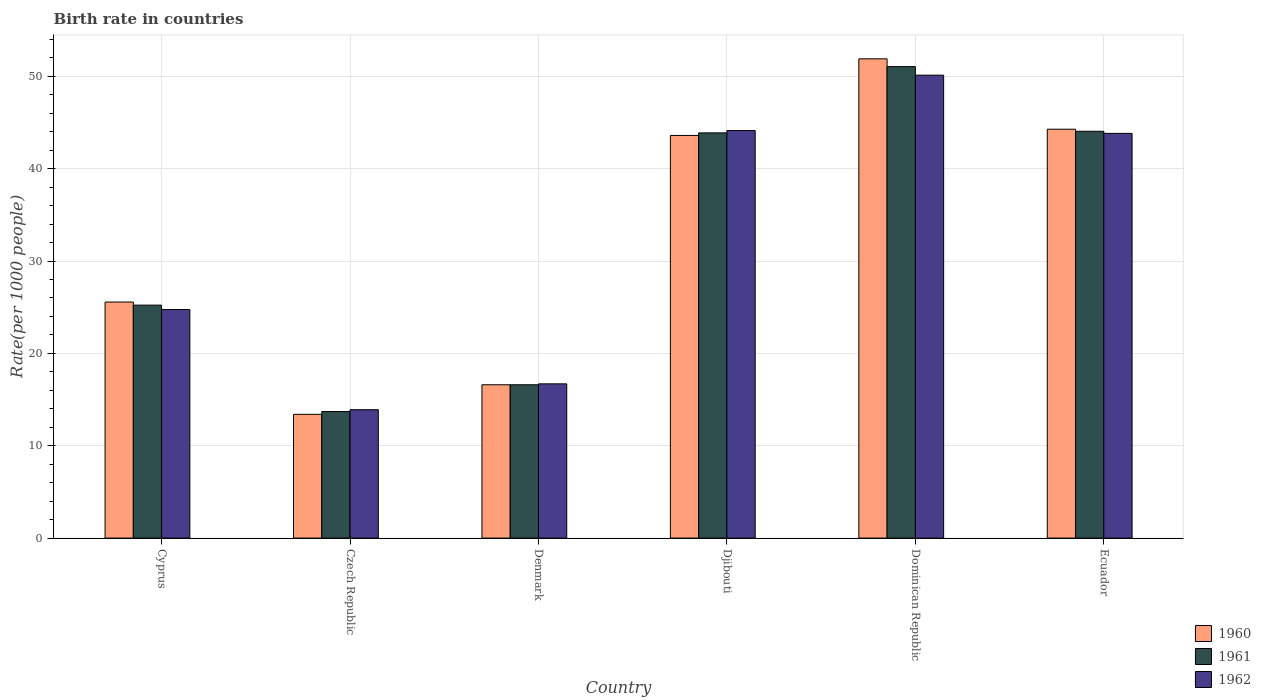How many groups of bars are there?
Your response must be concise. 6. Are the number of bars per tick equal to the number of legend labels?
Your response must be concise. Yes. How many bars are there on the 4th tick from the right?
Make the answer very short. 3. What is the label of the 1st group of bars from the left?
Keep it short and to the point. Cyprus. What is the birth rate in 1961 in Czech Republic?
Offer a very short reply. 13.7. Across all countries, what is the maximum birth rate in 1962?
Provide a short and direct response. 50.12. In which country was the birth rate in 1962 maximum?
Provide a succinct answer. Dominican Republic. In which country was the birth rate in 1960 minimum?
Your answer should be very brief. Czech Republic. What is the total birth rate in 1960 in the graph?
Ensure brevity in your answer.  195.31. What is the difference between the birth rate in 1962 in Czech Republic and that in Djibouti?
Make the answer very short. -30.23. What is the difference between the birth rate in 1962 in Djibouti and the birth rate in 1961 in Dominican Republic?
Provide a short and direct response. -6.92. What is the average birth rate in 1962 per country?
Provide a succinct answer. 32.24. What is the ratio of the birth rate in 1960 in Czech Republic to that in Ecuador?
Ensure brevity in your answer.  0.3. Is the difference between the birth rate in 1960 in Djibouti and Ecuador greater than the difference between the birth rate in 1962 in Djibouti and Ecuador?
Offer a very short reply. No. What is the difference between the highest and the second highest birth rate in 1960?
Your answer should be compact. -8.29. What is the difference between the highest and the lowest birth rate in 1961?
Keep it short and to the point. 37.35. Is the sum of the birth rate in 1961 in Czech Republic and Dominican Republic greater than the maximum birth rate in 1960 across all countries?
Provide a succinct answer. Yes. What does the 2nd bar from the right in Djibouti represents?
Make the answer very short. 1961. Is it the case that in every country, the sum of the birth rate in 1960 and birth rate in 1961 is greater than the birth rate in 1962?
Keep it short and to the point. Yes. How many bars are there?
Provide a succinct answer. 18. Are all the bars in the graph horizontal?
Make the answer very short. No. How many countries are there in the graph?
Keep it short and to the point. 6. Are the values on the major ticks of Y-axis written in scientific E-notation?
Ensure brevity in your answer.  No. Does the graph contain any zero values?
Ensure brevity in your answer.  No. Does the graph contain grids?
Keep it short and to the point. Yes. How many legend labels are there?
Keep it short and to the point. 3. What is the title of the graph?
Ensure brevity in your answer.  Birth rate in countries. What is the label or title of the Y-axis?
Your answer should be very brief. Rate(per 1000 people). What is the Rate(per 1000 people) of 1960 in Cyprus?
Offer a very short reply. 25.56. What is the Rate(per 1000 people) of 1961 in Cyprus?
Your response must be concise. 25.22. What is the Rate(per 1000 people) in 1962 in Cyprus?
Give a very brief answer. 24.75. What is the Rate(per 1000 people) of 1962 in Czech Republic?
Provide a short and direct response. 13.9. What is the Rate(per 1000 people) of 1960 in Denmark?
Offer a terse response. 16.6. What is the Rate(per 1000 people) in 1960 in Djibouti?
Ensure brevity in your answer.  43.59. What is the Rate(per 1000 people) of 1961 in Djibouti?
Offer a very short reply. 43.87. What is the Rate(per 1000 people) in 1962 in Djibouti?
Provide a succinct answer. 44.12. What is the Rate(per 1000 people) in 1960 in Dominican Republic?
Keep it short and to the point. 51.89. What is the Rate(per 1000 people) in 1961 in Dominican Republic?
Make the answer very short. 51.05. What is the Rate(per 1000 people) in 1962 in Dominican Republic?
Provide a short and direct response. 50.12. What is the Rate(per 1000 people) in 1960 in Ecuador?
Ensure brevity in your answer.  44.27. What is the Rate(per 1000 people) in 1961 in Ecuador?
Provide a short and direct response. 44.05. What is the Rate(per 1000 people) of 1962 in Ecuador?
Your response must be concise. 43.82. Across all countries, what is the maximum Rate(per 1000 people) of 1960?
Provide a short and direct response. 51.89. Across all countries, what is the maximum Rate(per 1000 people) of 1961?
Ensure brevity in your answer.  51.05. Across all countries, what is the maximum Rate(per 1000 people) of 1962?
Give a very brief answer. 50.12. Across all countries, what is the minimum Rate(per 1000 people) of 1962?
Your response must be concise. 13.9. What is the total Rate(per 1000 people) of 1960 in the graph?
Provide a succinct answer. 195.31. What is the total Rate(per 1000 people) of 1961 in the graph?
Give a very brief answer. 194.49. What is the total Rate(per 1000 people) in 1962 in the graph?
Ensure brevity in your answer.  193.41. What is the difference between the Rate(per 1000 people) in 1960 in Cyprus and that in Czech Republic?
Offer a terse response. 12.16. What is the difference between the Rate(per 1000 people) in 1961 in Cyprus and that in Czech Republic?
Offer a very short reply. 11.52. What is the difference between the Rate(per 1000 people) in 1962 in Cyprus and that in Czech Republic?
Provide a short and direct response. 10.85. What is the difference between the Rate(per 1000 people) of 1960 in Cyprus and that in Denmark?
Provide a short and direct response. 8.96. What is the difference between the Rate(per 1000 people) in 1961 in Cyprus and that in Denmark?
Provide a short and direct response. 8.62. What is the difference between the Rate(per 1000 people) in 1962 in Cyprus and that in Denmark?
Your response must be concise. 8.05. What is the difference between the Rate(per 1000 people) in 1960 in Cyprus and that in Djibouti?
Your answer should be compact. -18.04. What is the difference between the Rate(per 1000 people) of 1961 in Cyprus and that in Djibouti?
Keep it short and to the point. -18.65. What is the difference between the Rate(per 1000 people) of 1962 in Cyprus and that in Djibouti?
Your answer should be compact. -19.38. What is the difference between the Rate(per 1000 people) of 1960 in Cyprus and that in Dominican Republic?
Offer a very short reply. -26.33. What is the difference between the Rate(per 1000 people) in 1961 in Cyprus and that in Dominican Republic?
Offer a very short reply. -25.83. What is the difference between the Rate(per 1000 people) of 1962 in Cyprus and that in Dominican Republic?
Your response must be concise. -25.38. What is the difference between the Rate(per 1000 people) in 1960 in Cyprus and that in Ecuador?
Make the answer very short. -18.71. What is the difference between the Rate(per 1000 people) of 1961 in Cyprus and that in Ecuador?
Keep it short and to the point. -18.82. What is the difference between the Rate(per 1000 people) of 1962 in Cyprus and that in Ecuador?
Your answer should be compact. -19.07. What is the difference between the Rate(per 1000 people) in 1961 in Czech Republic and that in Denmark?
Make the answer very short. -2.9. What is the difference between the Rate(per 1000 people) in 1962 in Czech Republic and that in Denmark?
Keep it short and to the point. -2.8. What is the difference between the Rate(per 1000 people) of 1960 in Czech Republic and that in Djibouti?
Your answer should be very brief. -30.2. What is the difference between the Rate(per 1000 people) of 1961 in Czech Republic and that in Djibouti?
Your response must be concise. -30.17. What is the difference between the Rate(per 1000 people) in 1962 in Czech Republic and that in Djibouti?
Offer a very short reply. -30.23. What is the difference between the Rate(per 1000 people) of 1960 in Czech Republic and that in Dominican Republic?
Provide a short and direct response. -38.49. What is the difference between the Rate(per 1000 people) in 1961 in Czech Republic and that in Dominican Republic?
Your answer should be very brief. -37.35. What is the difference between the Rate(per 1000 people) of 1962 in Czech Republic and that in Dominican Republic?
Offer a very short reply. -36.22. What is the difference between the Rate(per 1000 people) of 1960 in Czech Republic and that in Ecuador?
Keep it short and to the point. -30.87. What is the difference between the Rate(per 1000 people) of 1961 in Czech Republic and that in Ecuador?
Offer a very short reply. -30.35. What is the difference between the Rate(per 1000 people) in 1962 in Czech Republic and that in Ecuador?
Give a very brief answer. -29.92. What is the difference between the Rate(per 1000 people) of 1960 in Denmark and that in Djibouti?
Offer a very short reply. -27. What is the difference between the Rate(per 1000 people) of 1961 in Denmark and that in Djibouti?
Keep it short and to the point. -27.27. What is the difference between the Rate(per 1000 people) in 1962 in Denmark and that in Djibouti?
Your response must be concise. -27.43. What is the difference between the Rate(per 1000 people) of 1960 in Denmark and that in Dominican Republic?
Provide a short and direct response. -35.29. What is the difference between the Rate(per 1000 people) of 1961 in Denmark and that in Dominican Republic?
Offer a very short reply. -34.45. What is the difference between the Rate(per 1000 people) of 1962 in Denmark and that in Dominican Republic?
Ensure brevity in your answer.  -33.42. What is the difference between the Rate(per 1000 people) in 1960 in Denmark and that in Ecuador?
Offer a very short reply. -27.67. What is the difference between the Rate(per 1000 people) in 1961 in Denmark and that in Ecuador?
Keep it short and to the point. -27.45. What is the difference between the Rate(per 1000 people) of 1962 in Denmark and that in Ecuador?
Your answer should be very brief. -27.12. What is the difference between the Rate(per 1000 people) in 1960 in Djibouti and that in Dominican Republic?
Offer a very short reply. -8.29. What is the difference between the Rate(per 1000 people) in 1961 in Djibouti and that in Dominican Republic?
Your response must be concise. -7.18. What is the difference between the Rate(per 1000 people) of 1962 in Djibouti and that in Dominican Republic?
Your answer should be compact. -6. What is the difference between the Rate(per 1000 people) in 1960 in Djibouti and that in Ecuador?
Offer a terse response. -0.68. What is the difference between the Rate(per 1000 people) of 1961 in Djibouti and that in Ecuador?
Your answer should be very brief. -0.17. What is the difference between the Rate(per 1000 people) in 1962 in Djibouti and that in Ecuador?
Provide a succinct answer. 0.31. What is the difference between the Rate(per 1000 people) of 1960 in Dominican Republic and that in Ecuador?
Offer a terse response. 7.62. What is the difference between the Rate(per 1000 people) of 1961 in Dominican Republic and that in Ecuador?
Make the answer very short. 7. What is the difference between the Rate(per 1000 people) in 1962 in Dominican Republic and that in Ecuador?
Provide a short and direct response. 6.3. What is the difference between the Rate(per 1000 people) in 1960 in Cyprus and the Rate(per 1000 people) in 1961 in Czech Republic?
Provide a short and direct response. 11.86. What is the difference between the Rate(per 1000 people) of 1960 in Cyprus and the Rate(per 1000 people) of 1962 in Czech Republic?
Your answer should be compact. 11.66. What is the difference between the Rate(per 1000 people) in 1961 in Cyprus and the Rate(per 1000 people) in 1962 in Czech Republic?
Your answer should be very brief. 11.32. What is the difference between the Rate(per 1000 people) in 1960 in Cyprus and the Rate(per 1000 people) in 1961 in Denmark?
Offer a terse response. 8.96. What is the difference between the Rate(per 1000 people) in 1960 in Cyprus and the Rate(per 1000 people) in 1962 in Denmark?
Keep it short and to the point. 8.86. What is the difference between the Rate(per 1000 people) of 1961 in Cyprus and the Rate(per 1000 people) of 1962 in Denmark?
Offer a very short reply. 8.52. What is the difference between the Rate(per 1000 people) of 1960 in Cyprus and the Rate(per 1000 people) of 1961 in Djibouti?
Provide a succinct answer. -18.31. What is the difference between the Rate(per 1000 people) in 1960 in Cyprus and the Rate(per 1000 people) in 1962 in Djibouti?
Offer a terse response. -18.57. What is the difference between the Rate(per 1000 people) of 1961 in Cyprus and the Rate(per 1000 people) of 1962 in Djibouti?
Provide a short and direct response. -18.9. What is the difference between the Rate(per 1000 people) in 1960 in Cyprus and the Rate(per 1000 people) in 1961 in Dominican Republic?
Provide a succinct answer. -25.49. What is the difference between the Rate(per 1000 people) of 1960 in Cyprus and the Rate(per 1000 people) of 1962 in Dominican Republic?
Ensure brevity in your answer.  -24.56. What is the difference between the Rate(per 1000 people) of 1961 in Cyprus and the Rate(per 1000 people) of 1962 in Dominican Republic?
Provide a succinct answer. -24.9. What is the difference between the Rate(per 1000 people) of 1960 in Cyprus and the Rate(per 1000 people) of 1961 in Ecuador?
Provide a short and direct response. -18.49. What is the difference between the Rate(per 1000 people) of 1960 in Cyprus and the Rate(per 1000 people) of 1962 in Ecuador?
Ensure brevity in your answer.  -18.26. What is the difference between the Rate(per 1000 people) in 1961 in Cyprus and the Rate(per 1000 people) in 1962 in Ecuador?
Make the answer very short. -18.6. What is the difference between the Rate(per 1000 people) in 1960 in Czech Republic and the Rate(per 1000 people) in 1962 in Denmark?
Offer a very short reply. -3.3. What is the difference between the Rate(per 1000 people) in 1960 in Czech Republic and the Rate(per 1000 people) in 1961 in Djibouti?
Provide a succinct answer. -30.47. What is the difference between the Rate(per 1000 people) in 1960 in Czech Republic and the Rate(per 1000 people) in 1962 in Djibouti?
Your answer should be compact. -30.73. What is the difference between the Rate(per 1000 people) in 1961 in Czech Republic and the Rate(per 1000 people) in 1962 in Djibouti?
Offer a very short reply. -30.43. What is the difference between the Rate(per 1000 people) in 1960 in Czech Republic and the Rate(per 1000 people) in 1961 in Dominican Republic?
Provide a succinct answer. -37.65. What is the difference between the Rate(per 1000 people) in 1960 in Czech Republic and the Rate(per 1000 people) in 1962 in Dominican Republic?
Ensure brevity in your answer.  -36.72. What is the difference between the Rate(per 1000 people) of 1961 in Czech Republic and the Rate(per 1000 people) of 1962 in Dominican Republic?
Keep it short and to the point. -36.42. What is the difference between the Rate(per 1000 people) of 1960 in Czech Republic and the Rate(per 1000 people) of 1961 in Ecuador?
Your response must be concise. -30.65. What is the difference between the Rate(per 1000 people) in 1960 in Czech Republic and the Rate(per 1000 people) in 1962 in Ecuador?
Keep it short and to the point. -30.42. What is the difference between the Rate(per 1000 people) of 1961 in Czech Republic and the Rate(per 1000 people) of 1962 in Ecuador?
Provide a short and direct response. -30.12. What is the difference between the Rate(per 1000 people) of 1960 in Denmark and the Rate(per 1000 people) of 1961 in Djibouti?
Give a very brief answer. -27.27. What is the difference between the Rate(per 1000 people) in 1960 in Denmark and the Rate(per 1000 people) in 1962 in Djibouti?
Make the answer very short. -27.52. What is the difference between the Rate(per 1000 people) in 1961 in Denmark and the Rate(per 1000 people) in 1962 in Djibouti?
Provide a succinct answer. -27.52. What is the difference between the Rate(per 1000 people) of 1960 in Denmark and the Rate(per 1000 people) of 1961 in Dominican Republic?
Provide a short and direct response. -34.45. What is the difference between the Rate(per 1000 people) of 1960 in Denmark and the Rate(per 1000 people) of 1962 in Dominican Republic?
Provide a succinct answer. -33.52. What is the difference between the Rate(per 1000 people) of 1961 in Denmark and the Rate(per 1000 people) of 1962 in Dominican Republic?
Make the answer very short. -33.52. What is the difference between the Rate(per 1000 people) in 1960 in Denmark and the Rate(per 1000 people) in 1961 in Ecuador?
Ensure brevity in your answer.  -27.45. What is the difference between the Rate(per 1000 people) in 1960 in Denmark and the Rate(per 1000 people) in 1962 in Ecuador?
Provide a short and direct response. -27.22. What is the difference between the Rate(per 1000 people) of 1961 in Denmark and the Rate(per 1000 people) of 1962 in Ecuador?
Provide a short and direct response. -27.22. What is the difference between the Rate(per 1000 people) in 1960 in Djibouti and the Rate(per 1000 people) in 1961 in Dominican Republic?
Your response must be concise. -7.45. What is the difference between the Rate(per 1000 people) in 1960 in Djibouti and the Rate(per 1000 people) in 1962 in Dominican Republic?
Make the answer very short. -6.53. What is the difference between the Rate(per 1000 people) in 1961 in Djibouti and the Rate(per 1000 people) in 1962 in Dominican Republic?
Keep it short and to the point. -6.25. What is the difference between the Rate(per 1000 people) of 1960 in Djibouti and the Rate(per 1000 people) of 1961 in Ecuador?
Your response must be concise. -0.45. What is the difference between the Rate(per 1000 people) in 1960 in Djibouti and the Rate(per 1000 people) in 1962 in Ecuador?
Keep it short and to the point. -0.22. What is the difference between the Rate(per 1000 people) of 1961 in Djibouti and the Rate(per 1000 people) of 1962 in Ecuador?
Keep it short and to the point. 0.05. What is the difference between the Rate(per 1000 people) in 1960 in Dominican Republic and the Rate(per 1000 people) in 1961 in Ecuador?
Make the answer very short. 7.84. What is the difference between the Rate(per 1000 people) of 1960 in Dominican Republic and the Rate(per 1000 people) of 1962 in Ecuador?
Your answer should be compact. 8.07. What is the difference between the Rate(per 1000 people) of 1961 in Dominican Republic and the Rate(per 1000 people) of 1962 in Ecuador?
Offer a terse response. 7.23. What is the average Rate(per 1000 people) in 1960 per country?
Your response must be concise. 32.55. What is the average Rate(per 1000 people) in 1961 per country?
Give a very brief answer. 32.41. What is the average Rate(per 1000 people) of 1962 per country?
Your response must be concise. 32.24. What is the difference between the Rate(per 1000 people) of 1960 and Rate(per 1000 people) of 1961 in Cyprus?
Offer a terse response. 0.34. What is the difference between the Rate(per 1000 people) of 1960 and Rate(per 1000 people) of 1962 in Cyprus?
Your answer should be very brief. 0.81. What is the difference between the Rate(per 1000 people) of 1961 and Rate(per 1000 people) of 1962 in Cyprus?
Offer a very short reply. 0.48. What is the difference between the Rate(per 1000 people) in 1960 and Rate(per 1000 people) in 1961 in Czech Republic?
Give a very brief answer. -0.3. What is the difference between the Rate(per 1000 people) in 1960 and Rate(per 1000 people) in 1962 in Denmark?
Offer a very short reply. -0.1. What is the difference between the Rate(per 1000 people) in 1961 and Rate(per 1000 people) in 1962 in Denmark?
Your answer should be very brief. -0.1. What is the difference between the Rate(per 1000 people) in 1960 and Rate(per 1000 people) in 1961 in Djibouti?
Give a very brief answer. -0.28. What is the difference between the Rate(per 1000 people) in 1960 and Rate(per 1000 people) in 1962 in Djibouti?
Give a very brief answer. -0.53. What is the difference between the Rate(per 1000 people) of 1961 and Rate(per 1000 people) of 1962 in Djibouti?
Your response must be concise. -0.25. What is the difference between the Rate(per 1000 people) in 1960 and Rate(per 1000 people) in 1961 in Dominican Republic?
Ensure brevity in your answer.  0.84. What is the difference between the Rate(per 1000 people) in 1960 and Rate(per 1000 people) in 1962 in Dominican Republic?
Provide a short and direct response. 1.77. What is the difference between the Rate(per 1000 people) of 1961 and Rate(per 1000 people) of 1962 in Dominican Republic?
Make the answer very short. 0.93. What is the difference between the Rate(per 1000 people) of 1960 and Rate(per 1000 people) of 1961 in Ecuador?
Provide a succinct answer. 0.22. What is the difference between the Rate(per 1000 people) of 1960 and Rate(per 1000 people) of 1962 in Ecuador?
Make the answer very short. 0.45. What is the difference between the Rate(per 1000 people) of 1961 and Rate(per 1000 people) of 1962 in Ecuador?
Your answer should be very brief. 0.23. What is the ratio of the Rate(per 1000 people) of 1960 in Cyprus to that in Czech Republic?
Ensure brevity in your answer.  1.91. What is the ratio of the Rate(per 1000 people) in 1961 in Cyprus to that in Czech Republic?
Your response must be concise. 1.84. What is the ratio of the Rate(per 1000 people) of 1962 in Cyprus to that in Czech Republic?
Provide a succinct answer. 1.78. What is the ratio of the Rate(per 1000 people) of 1960 in Cyprus to that in Denmark?
Give a very brief answer. 1.54. What is the ratio of the Rate(per 1000 people) in 1961 in Cyprus to that in Denmark?
Your answer should be compact. 1.52. What is the ratio of the Rate(per 1000 people) in 1962 in Cyprus to that in Denmark?
Give a very brief answer. 1.48. What is the ratio of the Rate(per 1000 people) of 1960 in Cyprus to that in Djibouti?
Keep it short and to the point. 0.59. What is the ratio of the Rate(per 1000 people) in 1961 in Cyprus to that in Djibouti?
Provide a succinct answer. 0.57. What is the ratio of the Rate(per 1000 people) in 1962 in Cyprus to that in Djibouti?
Make the answer very short. 0.56. What is the ratio of the Rate(per 1000 people) of 1960 in Cyprus to that in Dominican Republic?
Make the answer very short. 0.49. What is the ratio of the Rate(per 1000 people) of 1961 in Cyprus to that in Dominican Republic?
Make the answer very short. 0.49. What is the ratio of the Rate(per 1000 people) in 1962 in Cyprus to that in Dominican Republic?
Keep it short and to the point. 0.49. What is the ratio of the Rate(per 1000 people) in 1960 in Cyprus to that in Ecuador?
Offer a very short reply. 0.58. What is the ratio of the Rate(per 1000 people) in 1961 in Cyprus to that in Ecuador?
Your answer should be compact. 0.57. What is the ratio of the Rate(per 1000 people) of 1962 in Cyprus to that in Ecuador?
Provide a succinct answer. 0.56. What is the ratio of the Rate(per 1000 people) in 1960 in Czech Republic to that in Denmark?
Keep it short and to the point. 0.81. What is the ratio of the Rate(per 1000 people) of 1961 in Czech Republic to that in Denmark?
Provide a short and direct response. 0.83. What is the ratio of the Rate(per 1000 people) in 1962 in Czech Republic to that in Denmark?
Provide a succinct answer. 0.83. What is the ratio of the Rate(per 1000 people) of 1960 in Czech Republic to that in Djibouti?
Your answer should be very brief. 0.31. What is the ratio of the Rate(per 1000 people) of 1961 in Czech Republic to that in Djibouti?
Ensure brevity in your answer.  0.31. What is the ratio of the Rate(per 1000 people) in 1962 in Czech Republic to that in Djibouti?
Ensure brevity in your answer.  0.32. What is the ratio of the Rate(per 1000 people) of 1960 in Czech Republic to that in Dominican Republic?
Offer a terse response. 0.26. What is the ratio of the Rate(per 1000 people) of 1961 in Czech Republic to that in Dominican Republic?
Your response must be concise. 0.27. What is the ratio of the Rate(per 1000 people) of 1962 in Czech Republic to that in Dominican Republic?
Provide a succinct answer. 0.28. What is the ratio of the Rate(per 1000 people) in 1960 in Czech Republic to that in Ecuador?
Make the answer very short. 0.3. What is the ratio of the Rate(per 1000 people) in 1961 in Czech Republic to that in Ecuador?
Offer a terse response. 0.31. What is the ratio of the Rate(per 1000 people) in 1962 in Czech Republic to that in Ecuador?
Ensure brevity in your answer.  0.32. What is the ratio of the Rate(per 1000 people) of 1960 in Denmark to that in Djibouti?
Offer a terse response. 0.38. What is the ratio of the Rate(per 1000 people) in 1961 in Denmark to that in Djibouti?
Ensure brevity in your answer.  0.38. What is the ratio of the Rate(per 1000 people) in 1962 in Denmark to that in Djibouti?
Provide a short and direct response. 0.38. What is the ratio of the Rate(per 1000 people) in 1960 in Denmark to that in Dominican Republic?
Offer a terse response. 0.32. What is the ratio of the Rate(per 1000 people) in 1961 in Denmark to that in Dominican Republic?
Make the answer very short. 0.33. What is the ratio of the Rate(per 1000 people) of 1962 in Denmark to that in Dominican Republic?
Provide a short and direct response. 0.33. What is the ratio of the Rate(per 1000 people) in 1960 in Denmark to that in Ecuador?
Provide a short and direct response. 0.38. What is the ratio of the Rate(per 1000 people) in 1961 in Denmark to that in Ecuador?
Provide a succinct answer. 0.38. What is the ratio of the Rate(per 1000 people) in 1962 in Denmark to that in Ecuador?
Keep it short and to the point. 0.38. What is the ratio of the Rate(per 1000 people) in 1960 in Djibouti to that in Dominican Republic?
Your answer should be very brief. 0.84. What is the ratio of the Rate(per 1000 people) in 1961 in Djibouti to that in Dominican Republic?
Offer a very short reply. 0.86. What is the ratio of the Rate(per 1000 people) of 1962 in Djibouti to that in Dominican Republic?
Offer a very short reply. 0.88. What is the ratio of the Rate(per 1000 people) in 1960 in Djibouti to that in Ecuador?
Give a very brief answer. 0.98. What is the ratio of the Rate(per 1000 people) of 1960 in Dominican Republic to that in Ecuador?
Provide a succinct answer. 1.17. What is the ratio of the Rate(per 1000 people) of 1961 in Dominican Republic to that in Ecuador?
Your answer should be compact. 1.16. What is the ratio of the Rate(per 1000 people) of 1962 in Dominican Republic to that in Ecuador?
Make the answer very short. 1.14. What is the difference between the highest and the second highest Rate(per 1000 people) in 1960?
Make the answer very short. 7.62. What is the difference between the highest and the second highest Rate(per 1000 people) in 1961?
Keep it short and to the point. 7. What is the difference between the highest and the second highest Rate(per 1000 people) in 1962?
Offer a very short reply. 6. What is the difference between the highest and the lowest Rate(per 1000 people) in 1960?
Offer a very short reply. 38.49. What is the difference between the highest and the lowest Rate(per 1000 people) in 1961?
Keep it short and to the point. 37.35. What is the difference between the highest and the lowest Rate(per 1000 people) in 1962?
Make the answer very short. 36.22. 